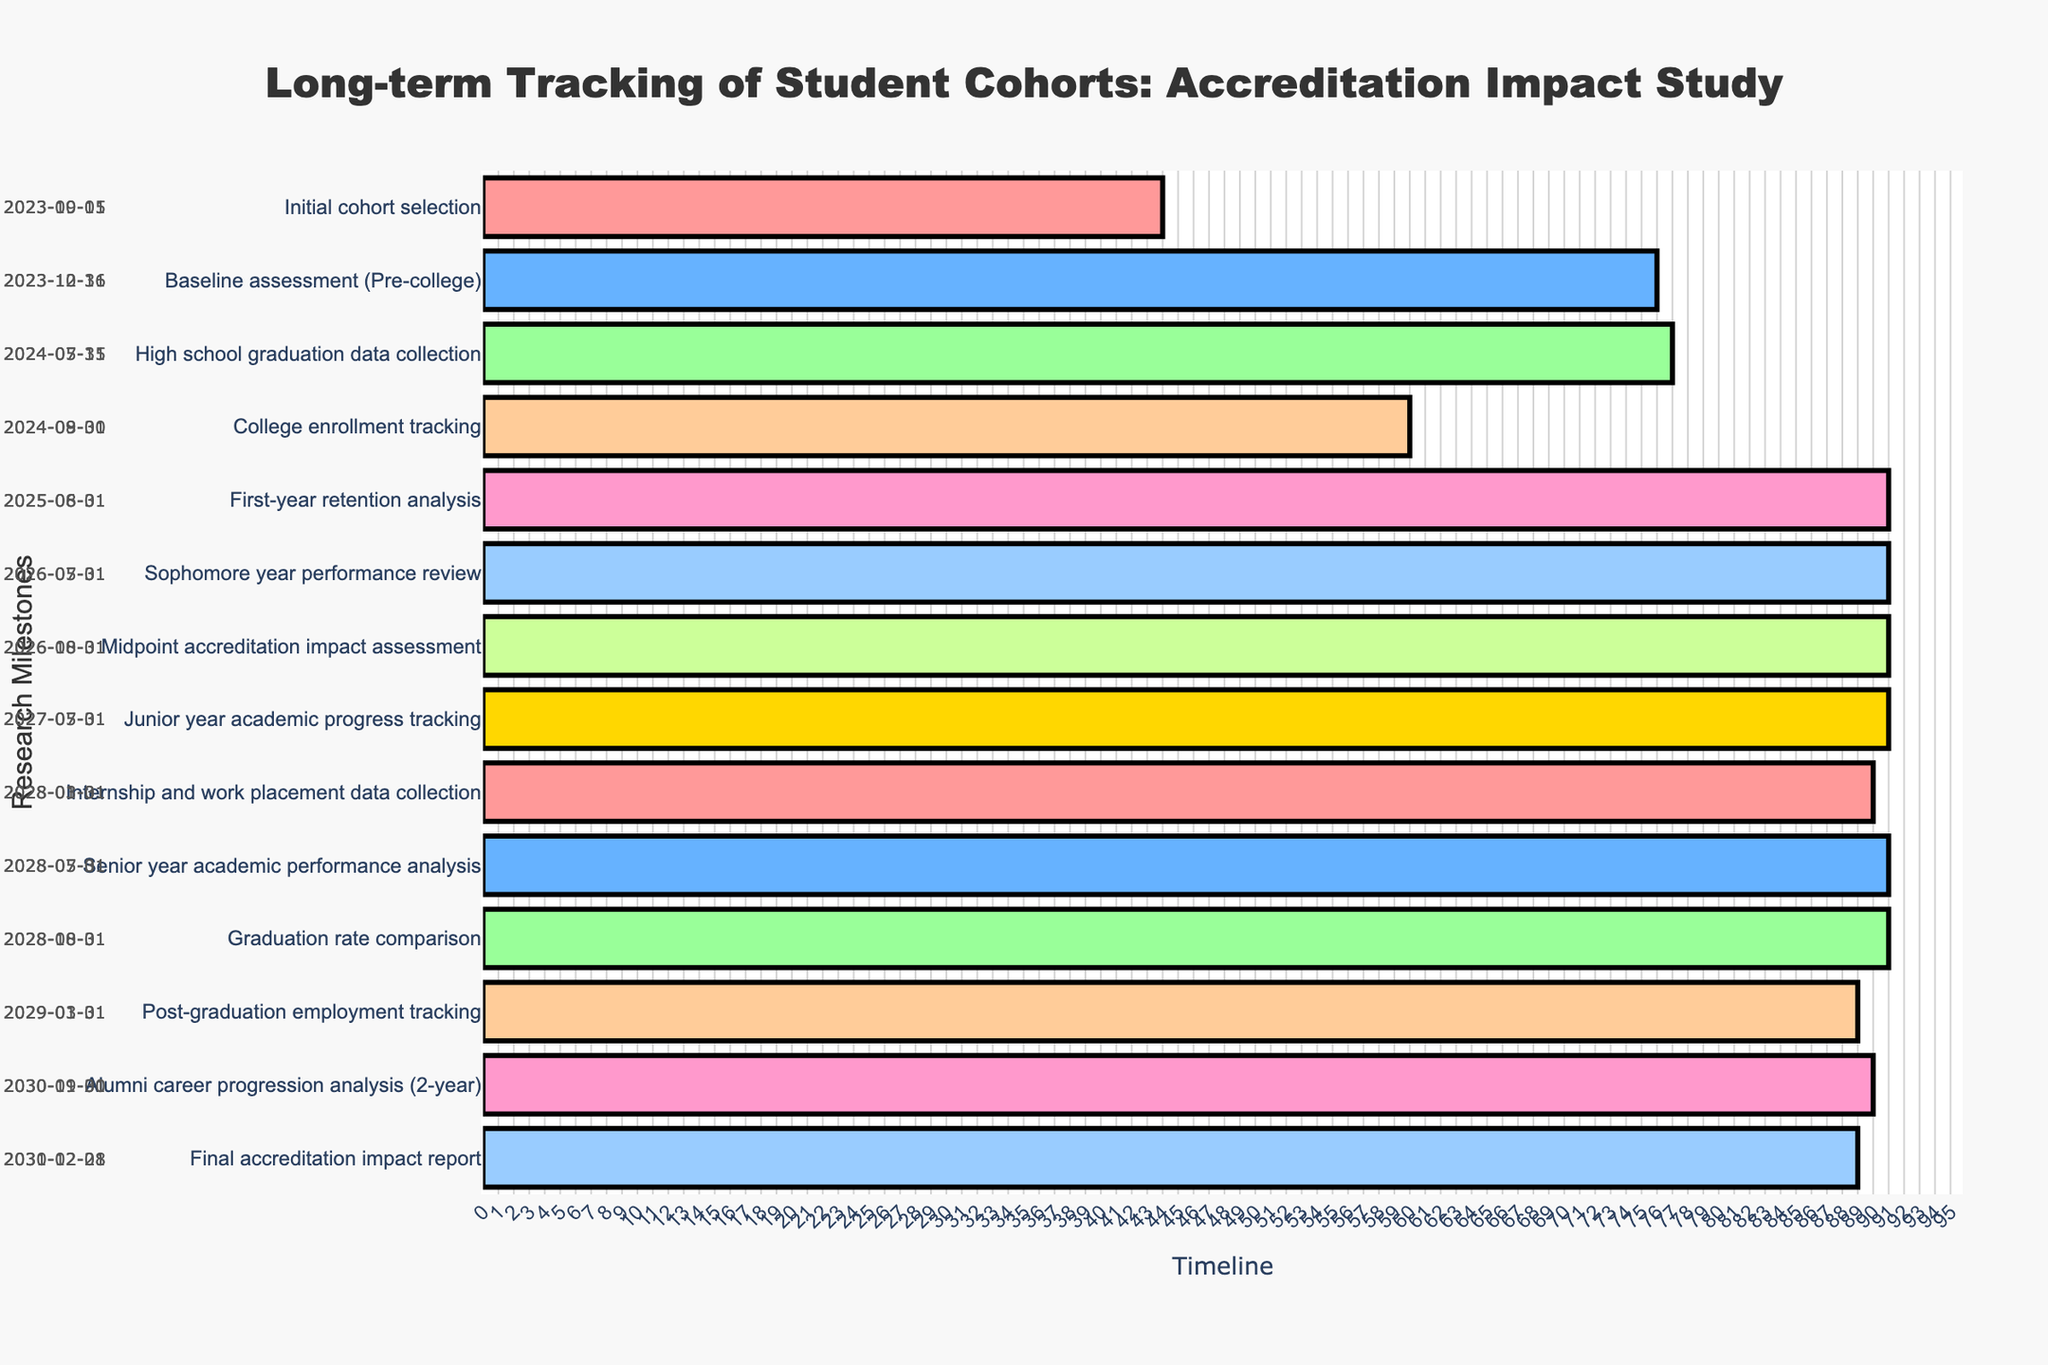What is the title of the Gantt chart? The title is usually located at the top of the chart and provides a summary of what the chart represents. In this case, the title would be written prominently above the bars.
Answer: Long-term Tracking of Student Cohorts: Accreditation Impact Study What are the start and end dates for the "Baseline assessment (Pre-college)" task? To find the start and end dates, locate the "Baseline assessment (Pre-college)" task in the figure and read the annotated dates on either end of the corresponding bar.
Answer: 2023-10-16 to 2023-12-31 How long is the "Junior year academic progress tracking" task in days? Check the length of the bar corresponding to the "Junior year academic progress tracking" task and read the duration.
Answer: 92 days Which task has the longest duration? Compare the lengths of all the tasks to determine which bar is the longest, indicating the task with the longest duration.
Answer: Baseline assessment (Pre-college) Which tasks are scheduled to start in 2028? Look at the start dates for all tasks and identify which ones begin in the year 2028.
Answer: Internship and work placement data collection, Senior year academic performance analysis, Graduation rate comparison What is the time difference between the end of "College enrollment tracking" and the start of "First-year retention analysis"? Identify the end date of "College enrollment tracking" and the start date of "First-year retention analysis", then calculate the difference between these dates.
Answer: 8 months How many tasks are scheduled to end within the year 2024? Identify the end dates of all tasks and count how many end within the range of 2024-01-01 to 2024-12-31.
Answer: 2 tasks From which tasks would you expect to see milestone annotations on the chart? Milestone annotations are typically shown for key phases such as major assessments, midpoint reviews, and final reports. Identify tasks with such characteristics.
Answer: Midpoint accreditation impact assessment, Final accreditation impact report Which task begins immediately after "Graduation rate comparison"? Identify the end date of "Graduation rate comparison" and find the next task that starts immediately after this date.
Answer: Post-graduation employment tracking How long after the start of the study is the "Final accreditation impact report" scheduled to begin? Find the start date of the initial task and the start date of the "Final accreditation impact report", then calculate the time between them.
Answer: Over 7 years 